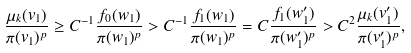Convert formula to latex. <formula><loc_0><loc_0><loc_500><loc_500>\frac { \mu _ { k } ( v _ { 1 } ) } { \pi ( v _ { 1 } ) ^ { p } } \geq C ^ { - 1 } \frac { f _ { 0 } ( w _ { 1 } ) } { \pi ( w _ { 1 } ) ^ { p } } > C ^ { - 1 } \frac { f _ { 1 } ( w _ { 1 } ) } { \pi ( w _ { 1 } ) ^ { p } } = C \frac { f _ { 1 } ( w _ { 1 } ^ { \prime } ) } { \pi ( w _ { 1 } ^ { \prime } ) ^ { p } } > C ^ { 2 } \frac { \mu _ { k } ( v _ { 1 } ^ { \prime } ) } { \pi ( v _ { 1 } ^ { \prime } ) ^ { p } } ,</formula> 